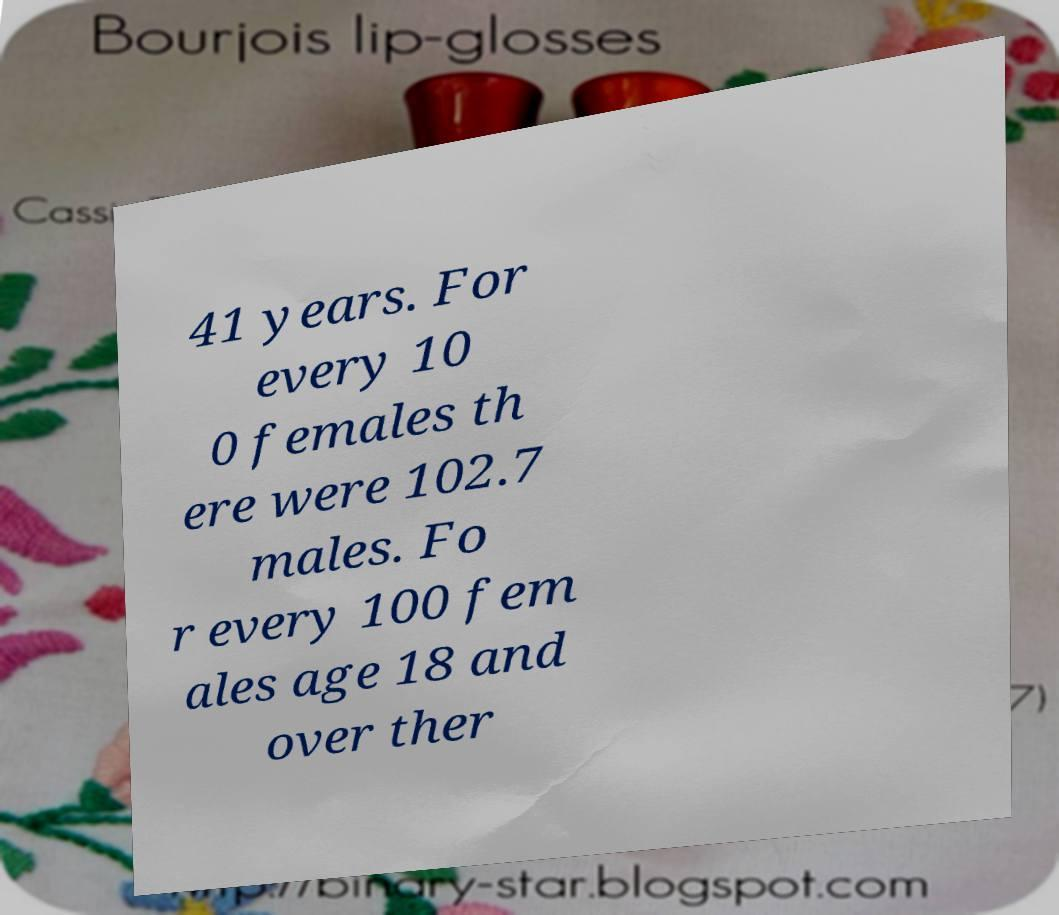Can you accurately transcribe the text from the provided image for me? 41 years. For every 10 0 females th ere were 102.7 males. Fo r every 100 fem ales age 18 and over ther 